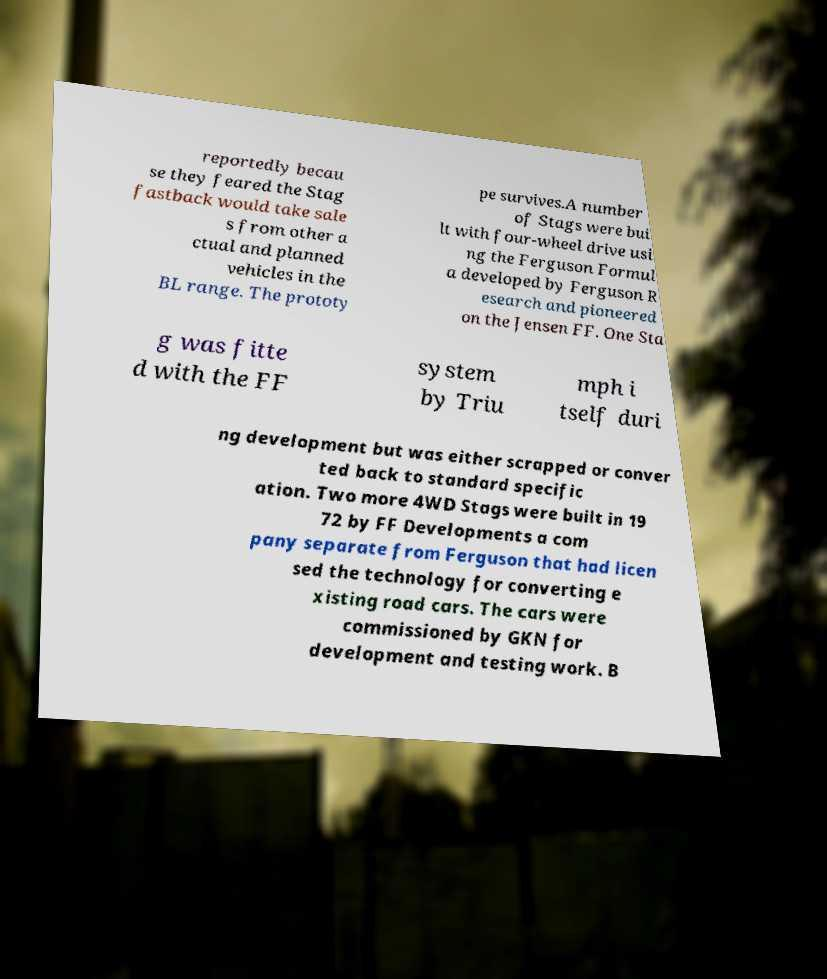Could you extract and type out the text from this image? reportedly becau se they feared the Stag fastback would take sale s from other a ctual and planned vehicles in the BL range. The prototy pe survives.A number of Stags were bui lt with four-wheel drive usi ng the Ferguson Formul a developed by Ferguson R esearch and pioneered on the Jensen FF. One Sta g was fitte d with the FF system by Triu mph i tself duri ng development but was either scrapped or conver ted back to standard specific ation. Two more 4WD Stags were built in 19 72 by FF Developments a com pany separate from Ferguson that had licen sed the technology for converting e xisting road cars. The cars were commissioned by GKN for development and testing work. B 